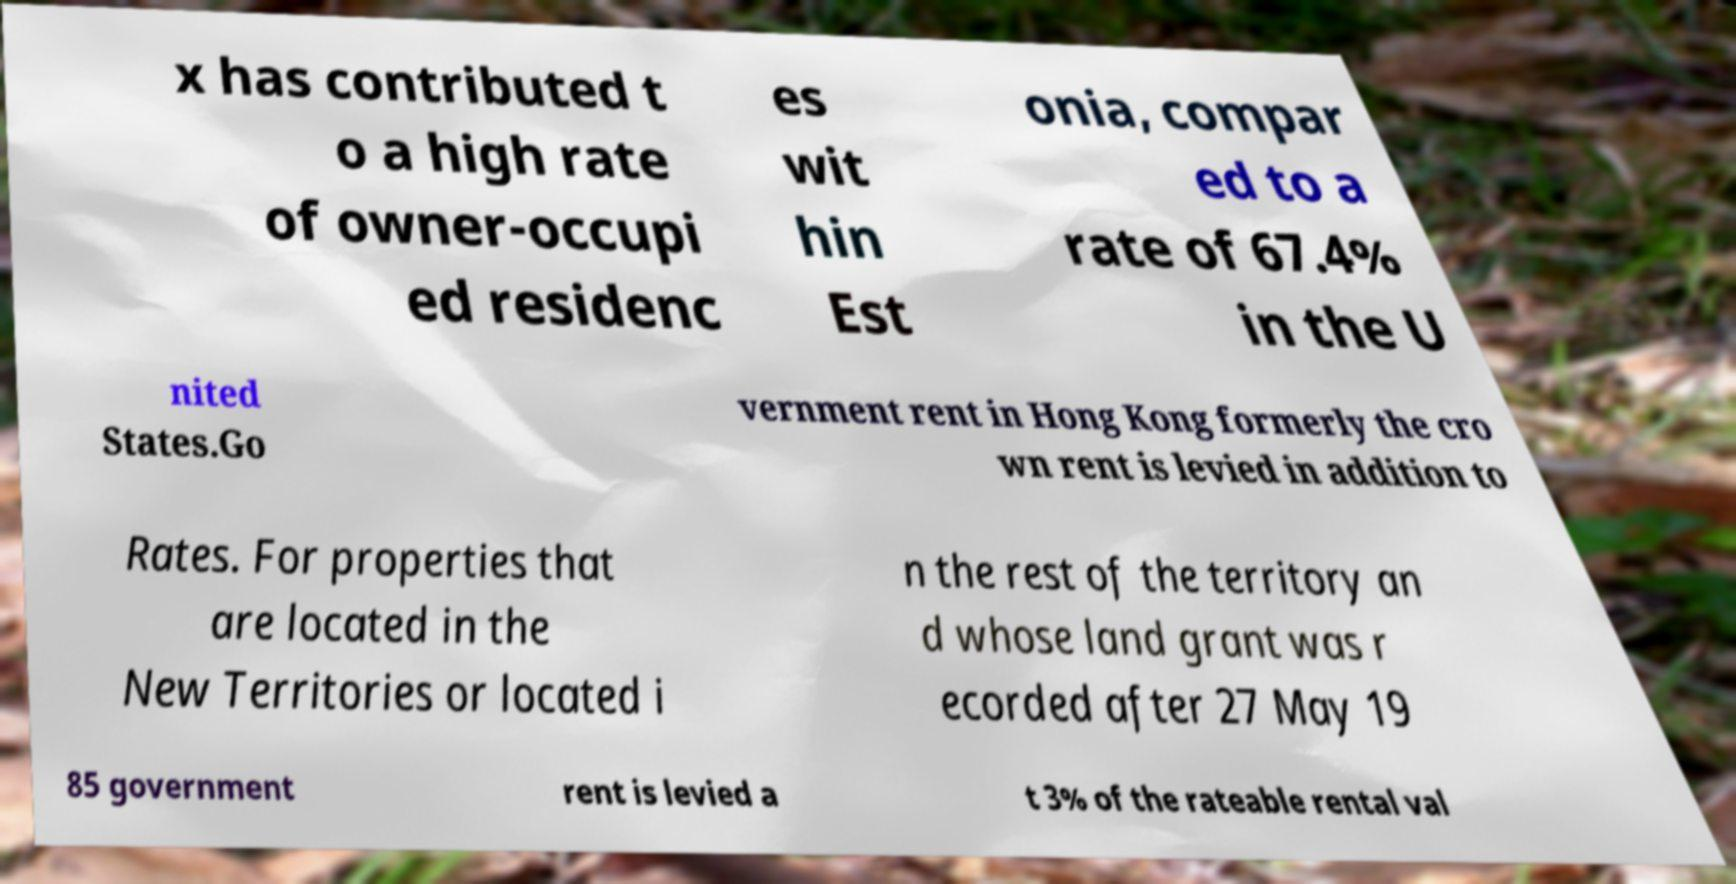Can you accurately transcribe the text from the provided image for me? x has contributed t o a high rate of owner-occupi ed residenc es wit hin Est onia, compar ed to a rate of 67.4% in the U nited States.Go vernment rent in Hong Kong formerly the cro wn rent is levied in addition to Rates. For properties that are located in the New Territories or located i n the rest of the territory an d whose land grant was r ecorded after 27 May 19 85 government rent is levied a t 3% of the rateable rental val 